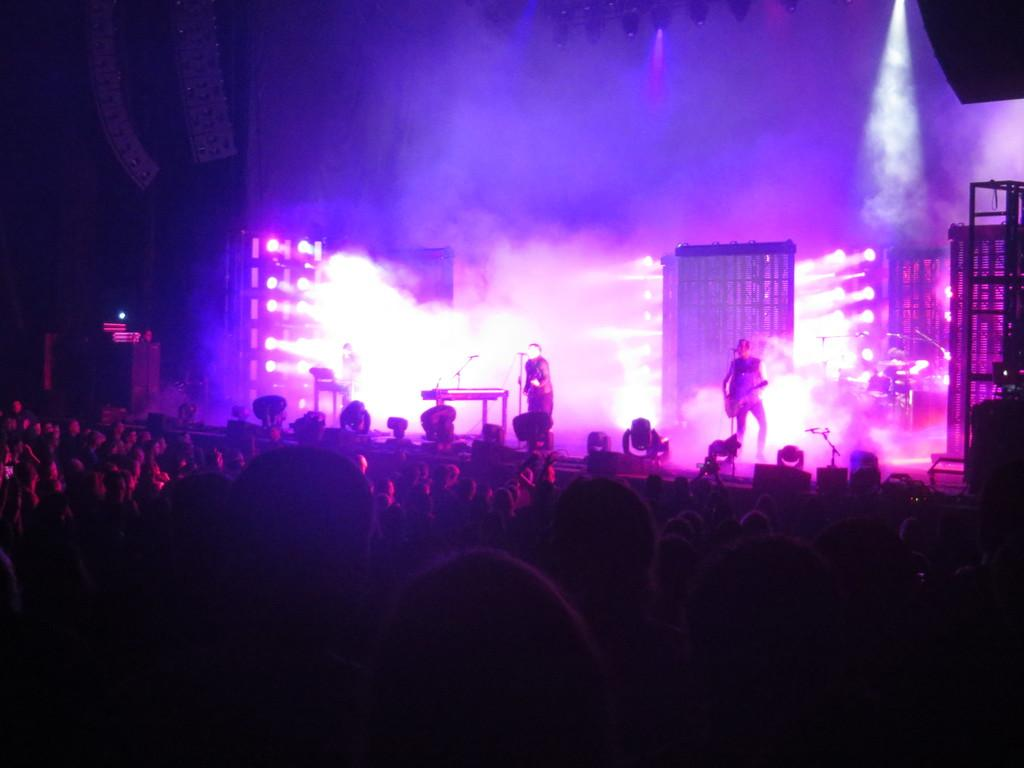What is happening on the stage in the image? There are two people standing on the stage. What can be seen at the bottom of the image? A crowd of people is present at the bottom of the image. What is visible in the background of the image? There are lights in the background of the image. What type of pie is being served to the crowd in the image? There is no pie present in the image; it features two people on a stage with a crowd at the bottom and lights in the background. 